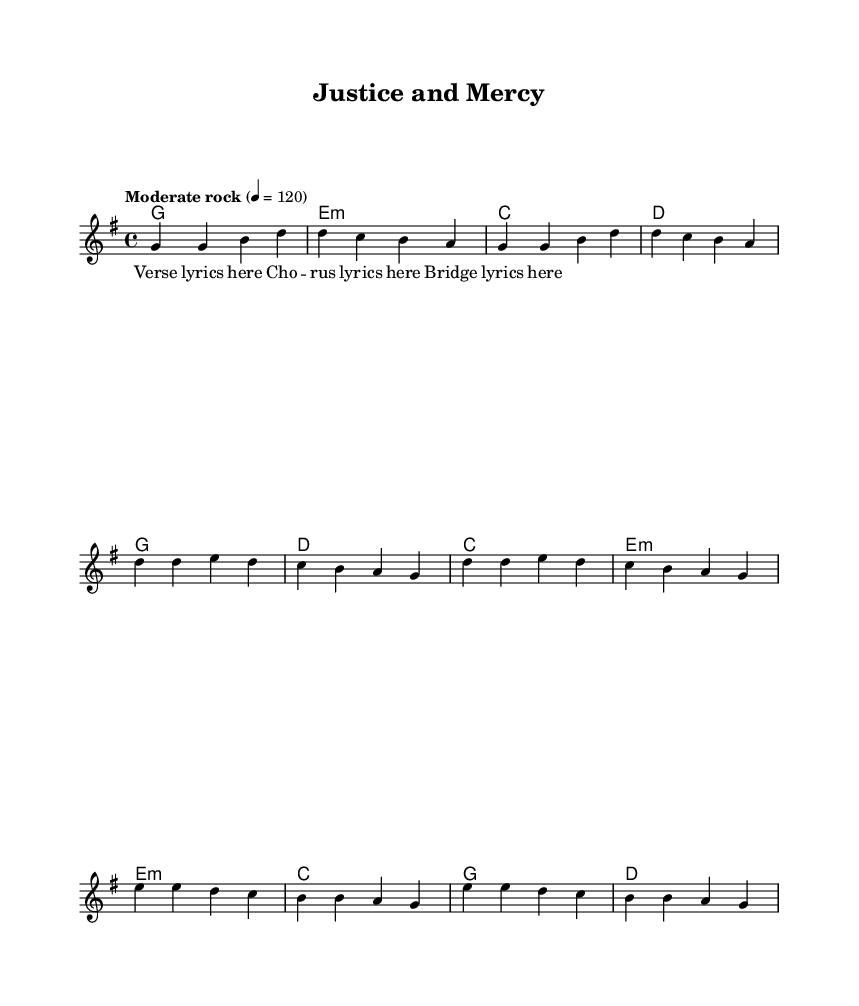What is the key signature of this music? The key signature is G major, which has one sharp (F#). This is indicated at the beginning of the sheet music, where it shows the key signature.
Answer: G major What is the time signature of this music? The time signature is 4/4, which means there are four beats in a measure and the quarter note gets one beat. This is visible at the beginning of the music notation.
Answer: 4/4 What is the tempo marking for this piece? The tempo marking is "Moderate rock," indicated at the beginning of the sheet music along with a metronome mark of 120 beats per minute.
Answer: Moderate rock How many sections does the music have? The music consists of three sections: verse, chorus, and bridge. This is evident in the structure of the lyrics and melody, as they are distinctly labeled.
Answer: Three What is the first chord played in the verse? The first chord played in the verse is G major, which is indicated in the chord line at the start of the verse section.
Answer: G major Which part of the song has the highest pitch? The bridge section contains the highest pitch, as it features higher melody notes compared to the verse and chorus. A quick comparison of the note placements confirms this.
Answer: Bridge What type of lyrics are featured in this song? The lyrics belong to a religious context, focusing on themes of justice and mercy as indicated by the title "Justice and Mercy." This context is common in Christian rock songs.
Answer: Religious 